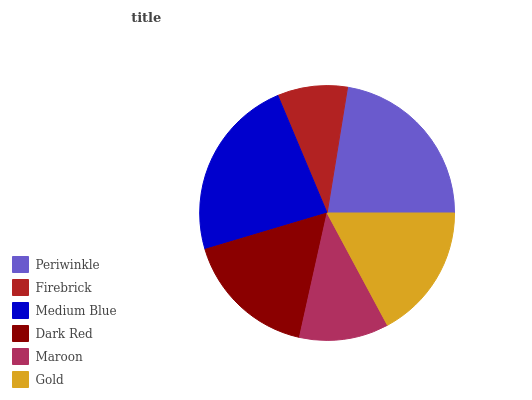Is Firebrick the minimum?
Answer yes or no. Yes. Is Medium Blue the maximum?
Answer yes or no. Yes. Is Medium Blue the minimum?
Answer yes or no. No. Is Firebrick the maximum?
Answer yes or no. No. Is Medium Blue greater than Firebrick?
Answer yes or no. Yes. Is Firebrick less than Medium Blue?
Answer yes or no. Yes. Is Firebrick greater than Medium Blue?
Answer yes or no. No. Is Medium Blue less than Firebrick?
Answer yes or no. No. Is Gold the high median?
Answer yes or no. Yes. Is Dark Red the low median?
Answer yes or no. Yes. Is Medium Blue the high median?
Answer yes or no. No. Is Firebrick the low median?
Answer yes or no. No. 